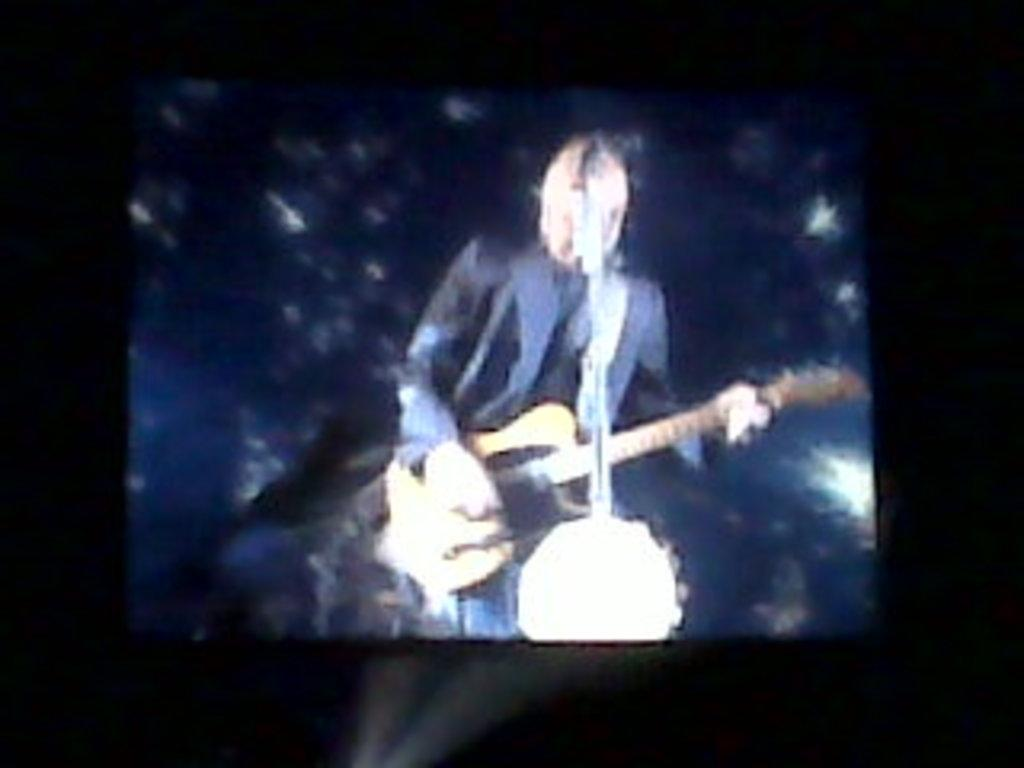What is the main subject of the image? There is a person in the image. What is the person doing in the image? The person is standing and playing a guitar. What object is present in the image that is commonly used for amplifying sound? There is a microphone in the image. Can you see any fairies dancing around the person playing the guitar in the image? There are no fairies present in the image. What type of prose is being recited by the person playing the guitar in the image? The person is playing a guitar, not reciting prose, in the image. 